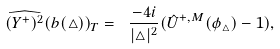Convert formula to latex. <formula><loc_0><loc_0><loc_500><loc_500>\widehat { ( Y ^ { + } ) ^ { 2 } } ( b ( \triangle ) ) _ { T } = \ \frac { - 4 i } { | \triangle | ^ { 2 } } ( { \hat { U } } ^ { + , M } ( { \phi _ { \triangle } } ) - 1 ) ,</formula> 